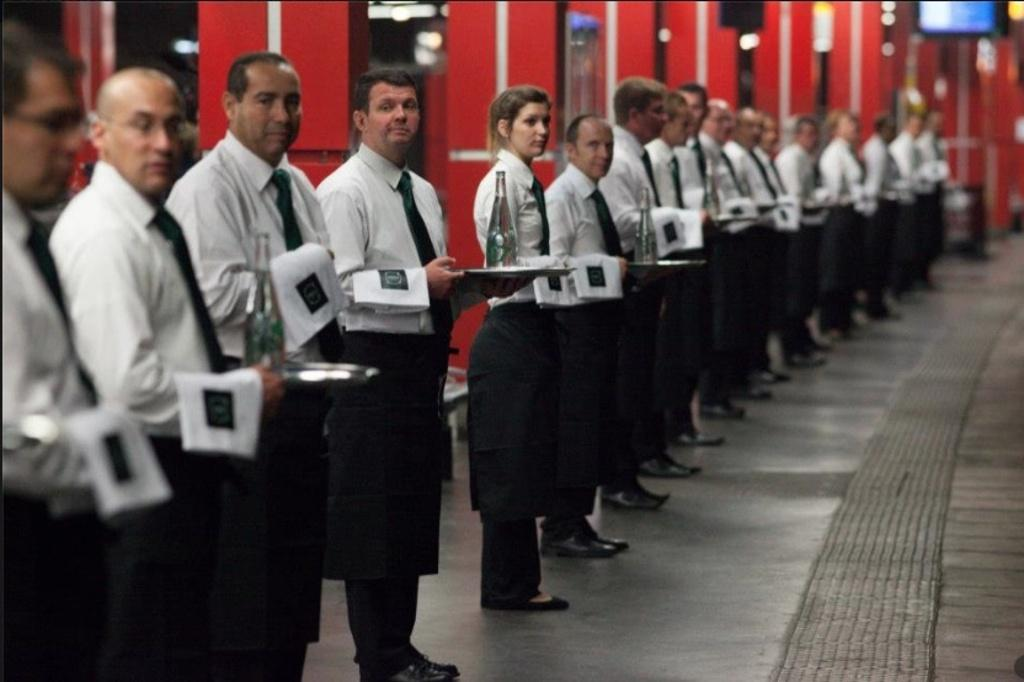What is happening in the image involving the group of people? The people in the image are standing and holding objects. What can be seen in the background of the image? There are pillars in the background of the image. Is there any additional feature in the top right corner of the image? Yes, there is a screen in the top right corner of the image. Can you see the ocean in the background of the image? No, there is no ocean visible in the image. The background features pillars, not an ocean. 